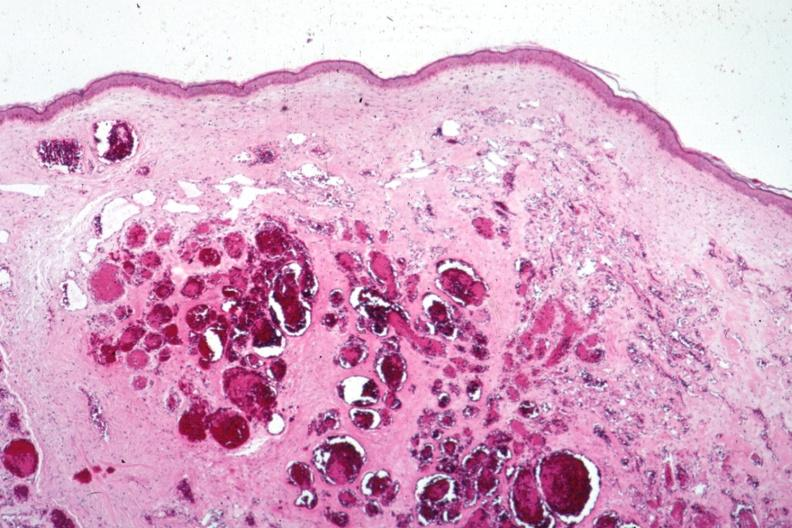s hemangioma present?
Answer the question using a single word or phrase. Yes 